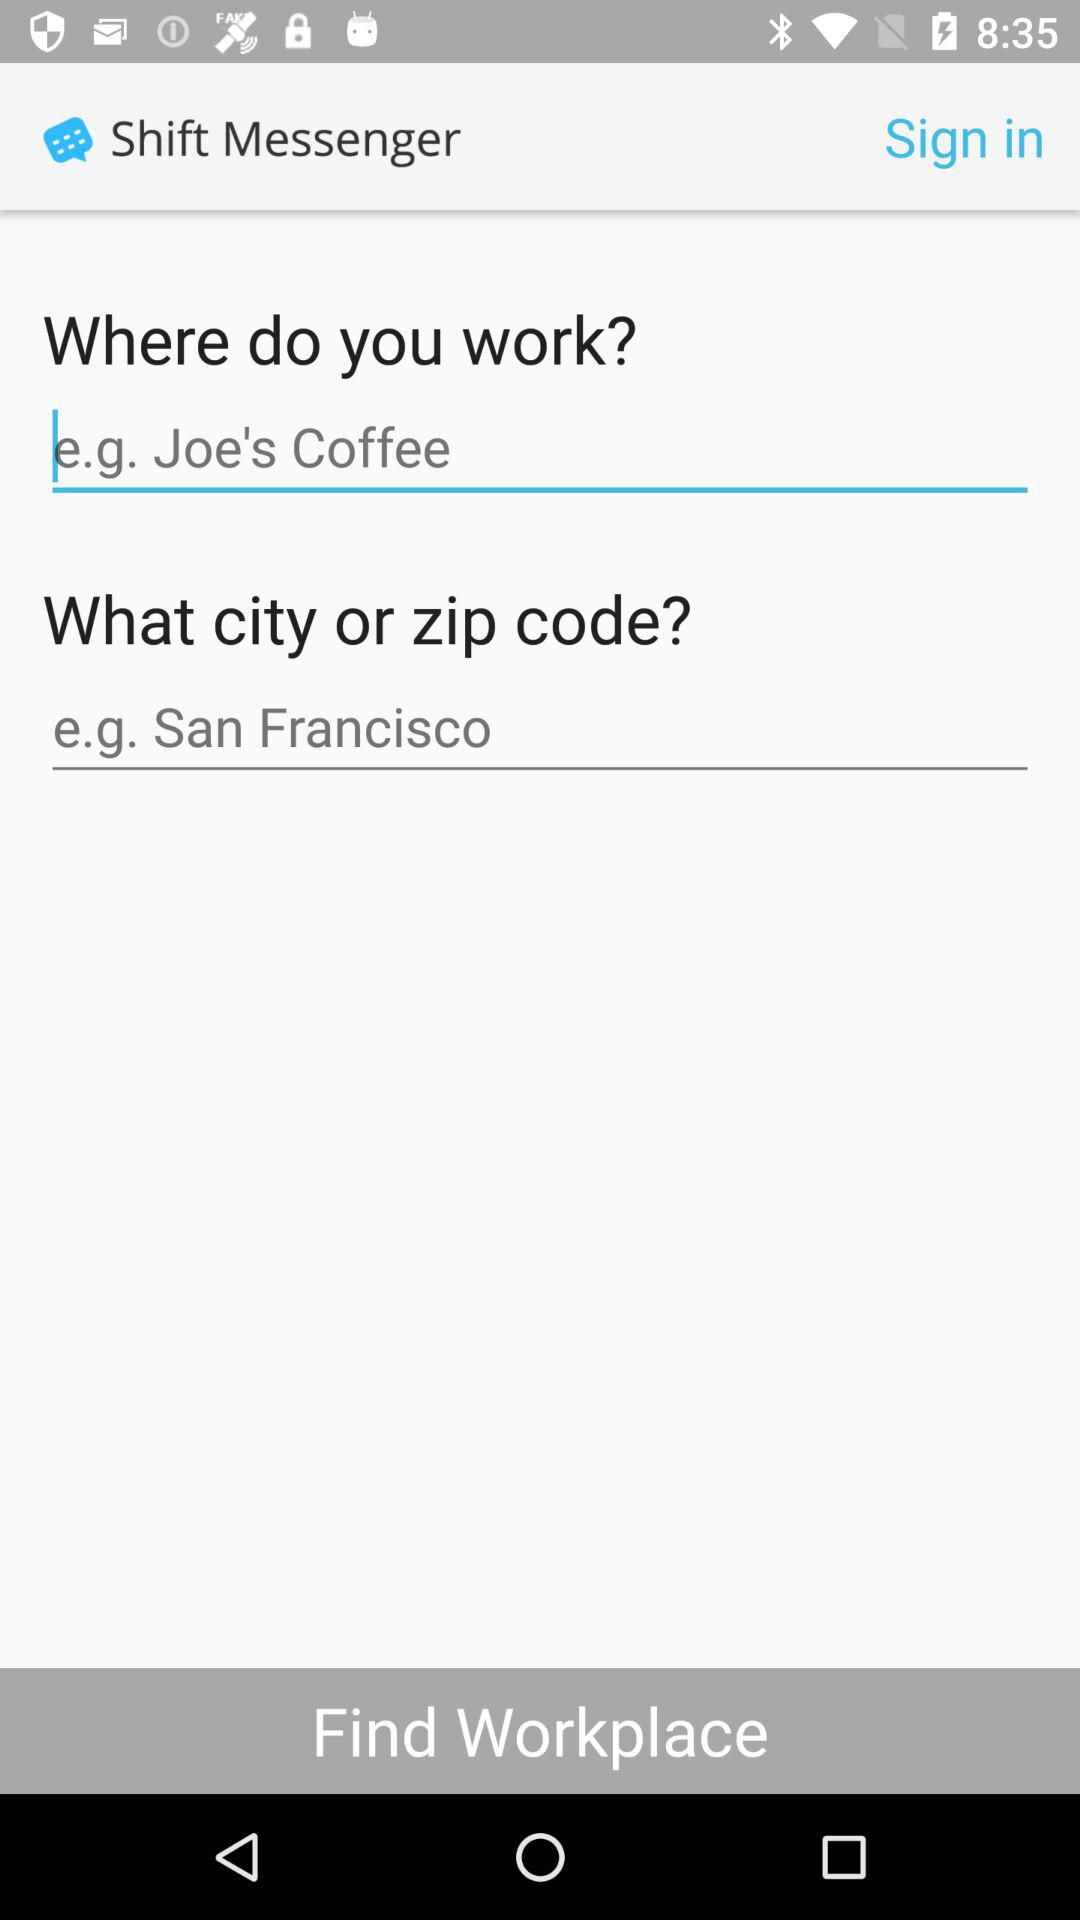What is the name of the application? The name of the application is "Shift Messenger". 